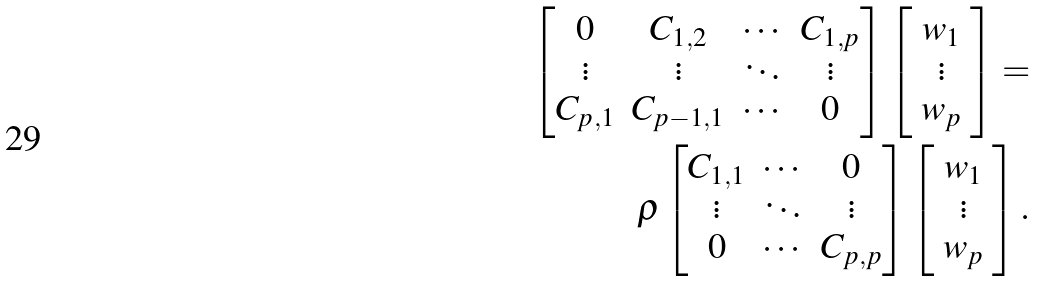Convert formula to latex. <formula><loc_0><loc_0><loc_500><loc_500>\begin{bmatrix} 0 & C _ { 1 , 2 } & \cdots & C _ { 1 , p } \\ \vdots & \vdots & \ddots & \vdots \\ C _ { p , 1 } & C _ { { p - 1 } , 1 } & \cdots & 0 \end{bmatrix} \left [ \begin{array} { c } w _ { 1 } \\ \vdots \\ w _ { p } \end{array} \right ] = & \\ \rho \begin{bmatrix} C _ { 1 , 1 } & \cdots & 0 \\ \vdots & \ddots & \vdots \\ 0 & \cdots & C _ { p , p } \end{bmatrix} \left [ \begin{array} { c } w _ { 1 } \\ \vdots \\ w _ { p } \end{array} \right ] .</formula> 